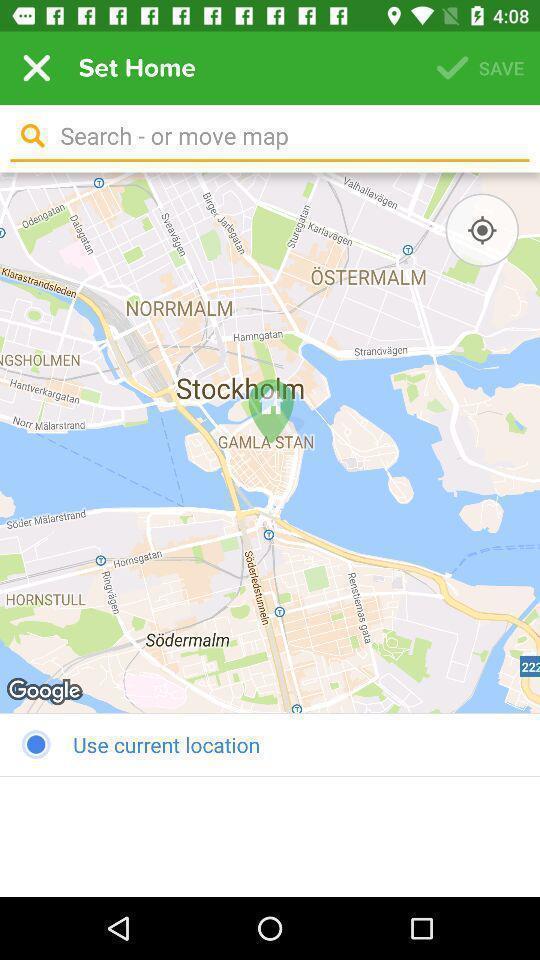Please provide a description for this image. Search bar in a mapping app. 